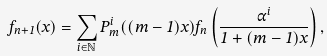Convert formula to latex. <formula><loc_0><loc_0><loc_500><loc_500>f _ { n + 1 } ( x ) = \sum _ { i \in \mathbb { N } } P _ { m } ^ { i } ( ( m - 1 ) x ) f _ { n } \left ( \frac { \alpha ^ { i } } { 1 + ( m - 1 ) x } \right ) ,</formula> 